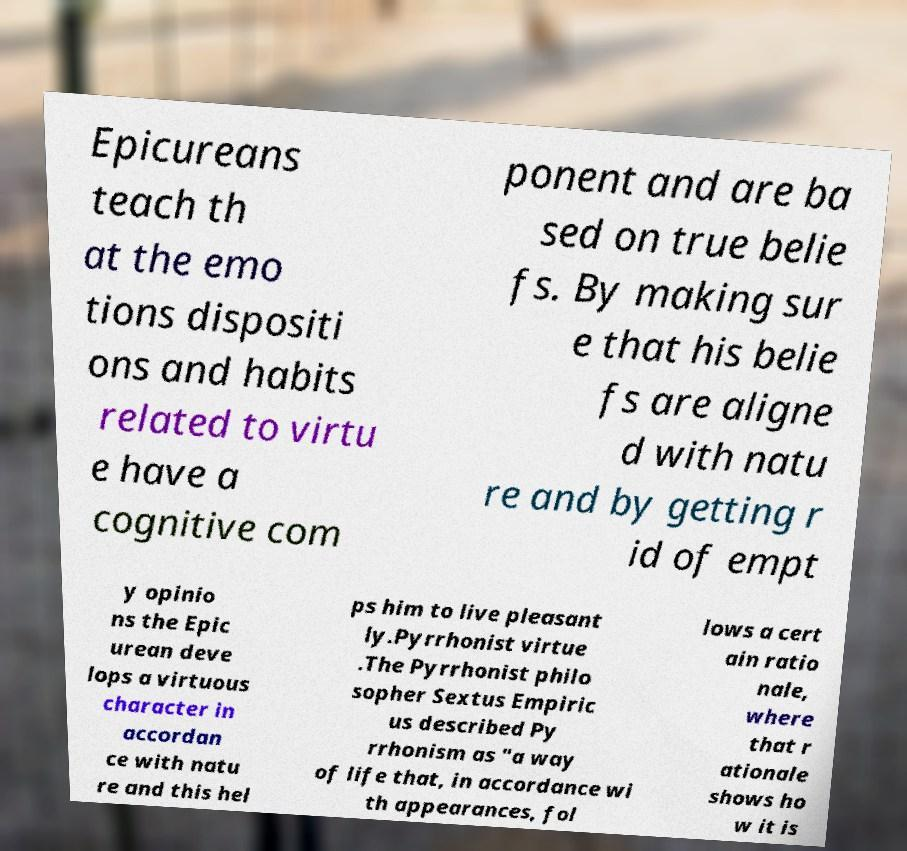Please identify and transcribe the text found in this image. Epicureans teach th at the emo tions dispositi ons and habits related to virtu e have a cognitive com ponent and are ba sed on true belie fs. By making sur e that his belie fs are aligne d with natu re and by getting r id of empt y opinio ns the Epic urean deve lops a virtuous character in accordan ce with natu re and this hel ps him to live pleasant ly.Pyrrhonist virtue .The Pyrrhonist philo sopher Sextus Empiric us described Py rrhonism as "a way of life that, in accordance wi th appearances, fol lows a cert ain ratio nale, where that r ationale shows ho w it is 